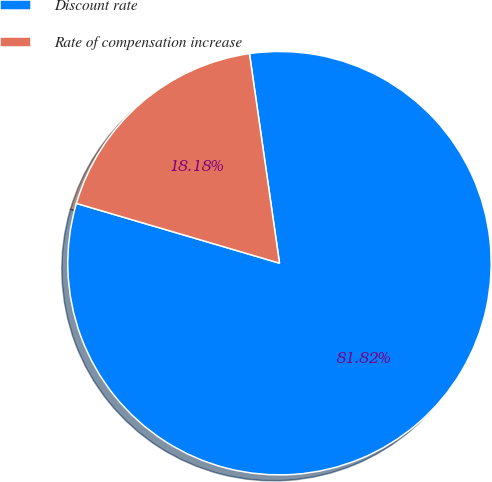Convert chart. <chart><loc_0><loc_0><loc_500><loc_500><pie_chart><fcel>Discount rate<fcel>Rate of compensation increase<nl><fcel>81.82%<fcel>18.18%<nl></chart> 